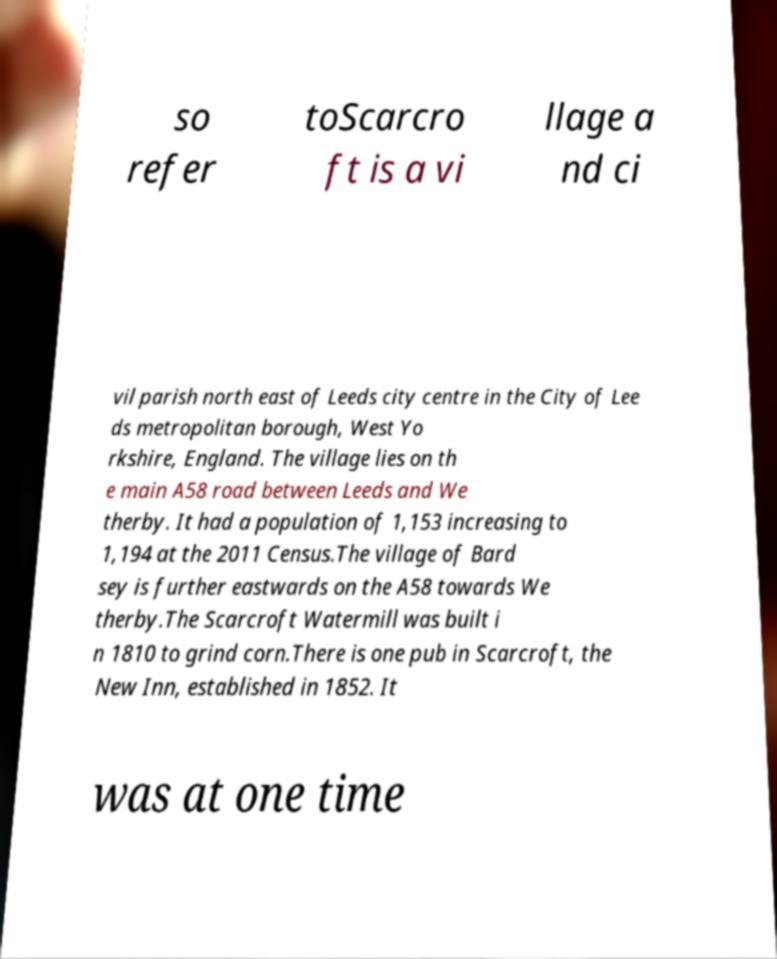I need the written content from this picture converted into text. Can you do that? so refer toScarcro ft is a vi llage a nd ci vil parish north east of Leeds city centre in the City of Lee ds metropolitan borough, West Yo rkshire, England. The village lies on th e main A58 road between Leeds and We therby. It had a population of 1,153 increasing to 1,194 at the 2011 Census.The village of Bard sey is further eastwards on the A58 towards We therby.The Scarcroft Watermill was built i n 1810 to grind corn.There is one pub in Scarcroft, the New Inn, established in 1852. It was at one time 